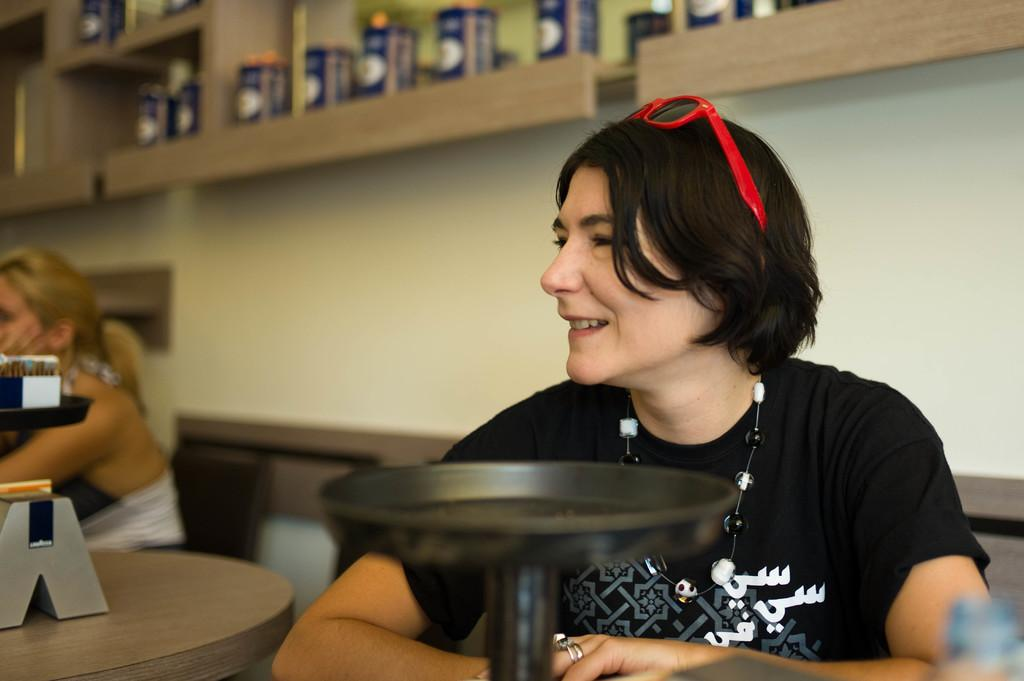Who is the main subject in the image? There is a woman in the image. What is the woman doing in the image? The woman is sitting in the image. What is the woman's facial expression in the image? The woman is smiling in the image. What accessory is the woman wearing on her head? The woman has goggles on her head in the image. What object is present in front of the woman? There is an object present in front of the woman in the image. How does the woman maintain her balance while sitting in the image? The image does not provide information about the woman's balance, so we cannot determine how she maintains her balance. 